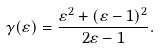Convert formula to latex. <formula><loc_0><loc_0><loc_500><loc_500>\gamma ( \varepsilon ) = \frac { \varepsilon ^ { 2 } + ( \varepsilon - 1 ) ^ { 2 } } { 2 \varepsilon - 1 } .</formula> 